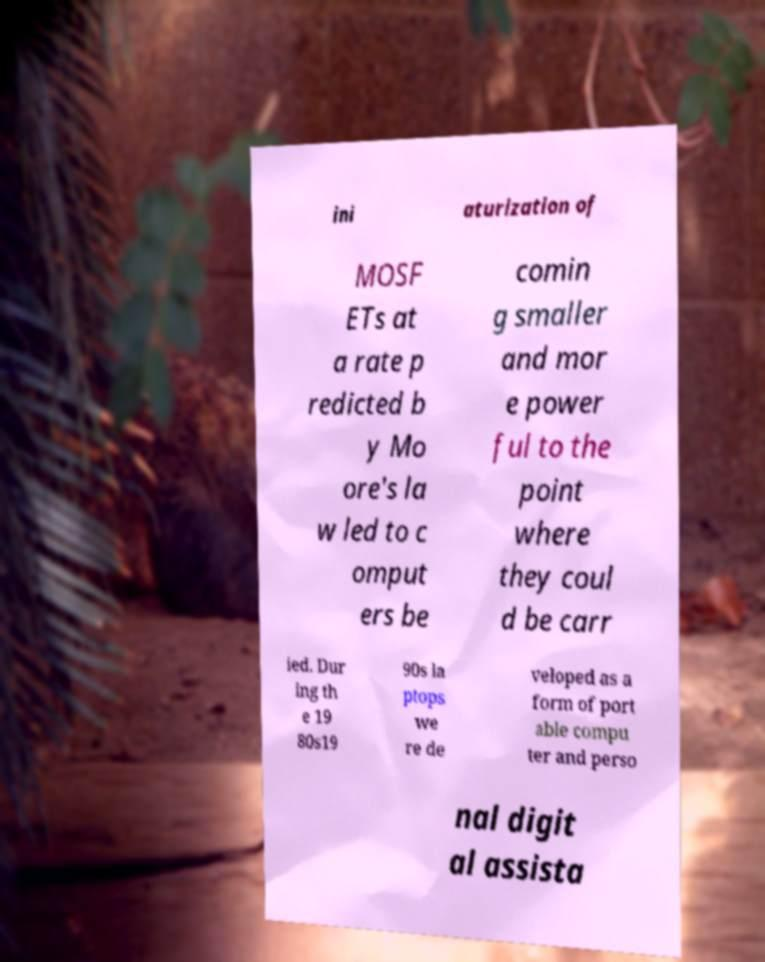I need the written content from this picture converted into text. Can you do that? ini aturization of MOSF ETs at a rate p redicted b y Mo ore's la w led to c omput ers be comin g smaller and mor e power ful to the point where they coul d be carr ied. Dur ing th e 19 80s19 90s la ptops we re de veloped as a form of port able compu ter and perso nal digit al assista 